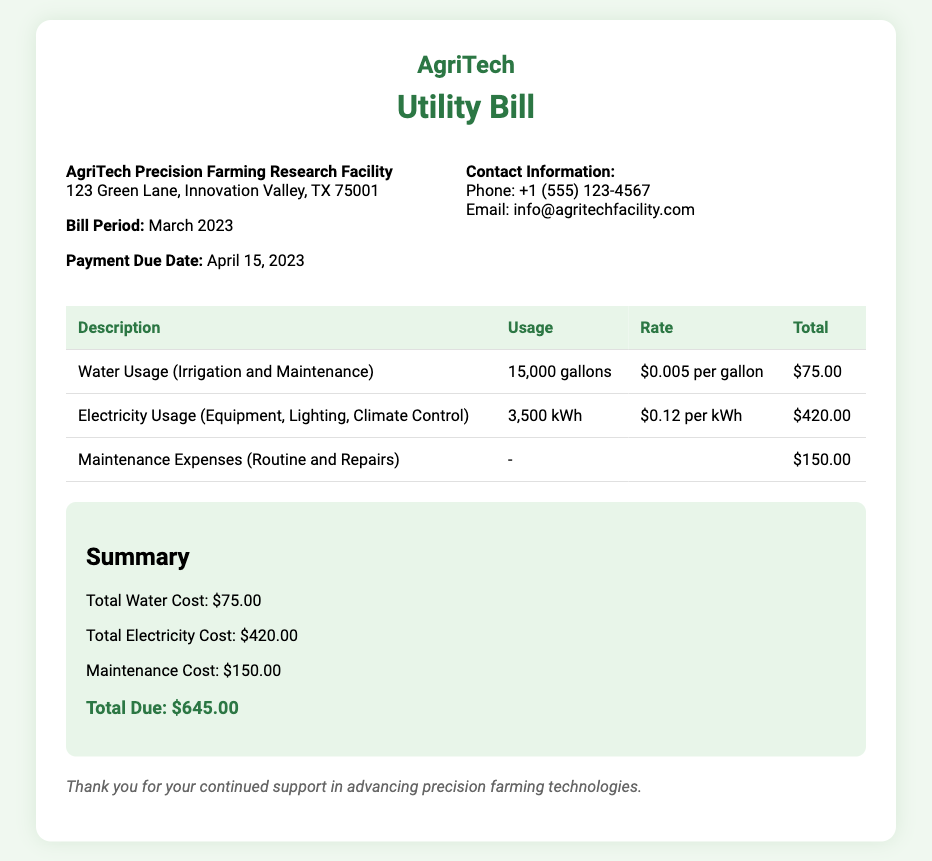What is the total due amount? The total due amount is listed in the summary section of the document, which adds up to $645.00.
Answer: $645.00 What is the electricity usage in March 2023? The document specifies that the electricity usage for the period is 3,500 kWh.
Answer: 3,500 kWh When is the payment due date? The payment due date is provided in the document, which states it is due on April 15, 2023.
Answer: April 15, 2023 What is the rate per gallon of water used? According to the document, the rate for water usage is $0.005 per gallon.
Answer: $0.005 per gallon What are the total maintenance expenses? The maintenance expenses are explicitly stated in the summary section as $150.00.
Answer: $150.00 What is the total cost of electricity? The total electricity cost is indicated in the summary and is calculated as $420.00.
Answer: $420.00 How many gallons of water were used? The document indicates that 15,000 gallons of water were used during the billing period.
Answer: 15,000 gallons What is the facility's address? The facility's address is provided in the details section of the document as 123 Green Lane, Innovation Valley, TX 75001.
Answer: 123 Green Lane, Innovation Valley, TX 75001 Which services are included in the maintenance expenses? The document mentions that routine and repairs are included in the maintenance expenses.
Answer: Routine and Repairs 